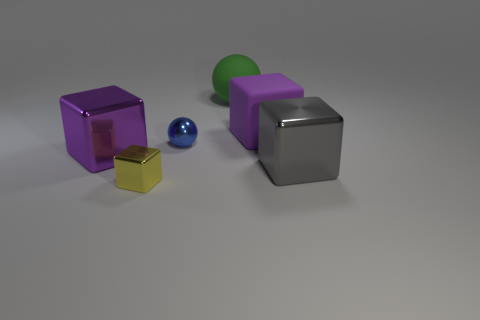What number of cubes are both to the left of the gray object and right of the tiny yellow cube?
Provide a succinct answer. 1. How many gray things are large blocks or cylinders?
Provide a succinct answer. 1. There is a tiny metallic object that is on the left side of the small sphere; is it the same color as the big shiny thing that is right of the yellow object?
Provide a succinct answer. No. There is a rubber object that is behind the big purple thing that is behind the sphere that is on the left side of the green matte thing; what is its color?
Make the answer very short. Green. Are there any purple things that are in front of the purple cube that is left of the yellow object?
Offer a terse response. No. Is the shape of the purple thing that is to the right of the yellow metal cube the same as  the blue object?
Ensure brevity in your answer.  No. Is there any other thing that has the same shape as the gray object?
Give a very brief answer. Yes. What number of blocks are either small metal objects or purple metal things?
Your answer should be very brief. 2. How many tiny metal things are there?
Offer a very short reply. 2. There is a cube behind the large shiny block left of the purple rubber block; what size is it?
Provide a short and direct response. Large. 